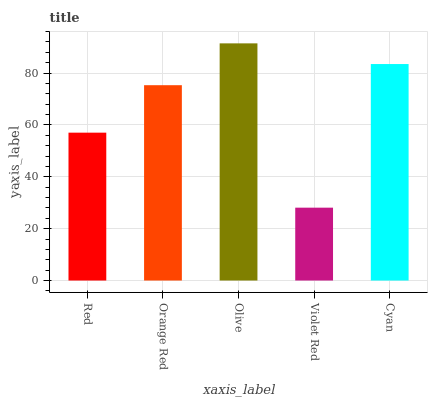Is Violet Red the minimum?
Answer yes or no. Yes. Is Olive the maximum?
Answer yes or no. Yes. Is Orange Red the minimum?
Answer yes or no. No. Is Orange Red the maximum?
Answer yes or no. No. Is Orange Red greater than Red?
Answer yes or no. Yes. Is Red less than Orange Red?
Answer yes or no. Yes. Is Red greater than Orange Red?
Answer yes or no. No. Is Orange Red less than Red?
Answer yes or no. No. Is Orange Red the high median?
Answer yes or no. Yes. Is Orange Red the low median?
Answer yes or no. Yes. Is Cyan the high median?
Answer yes or no. No. Is Olive the low median?
Answer yes or no. No. 